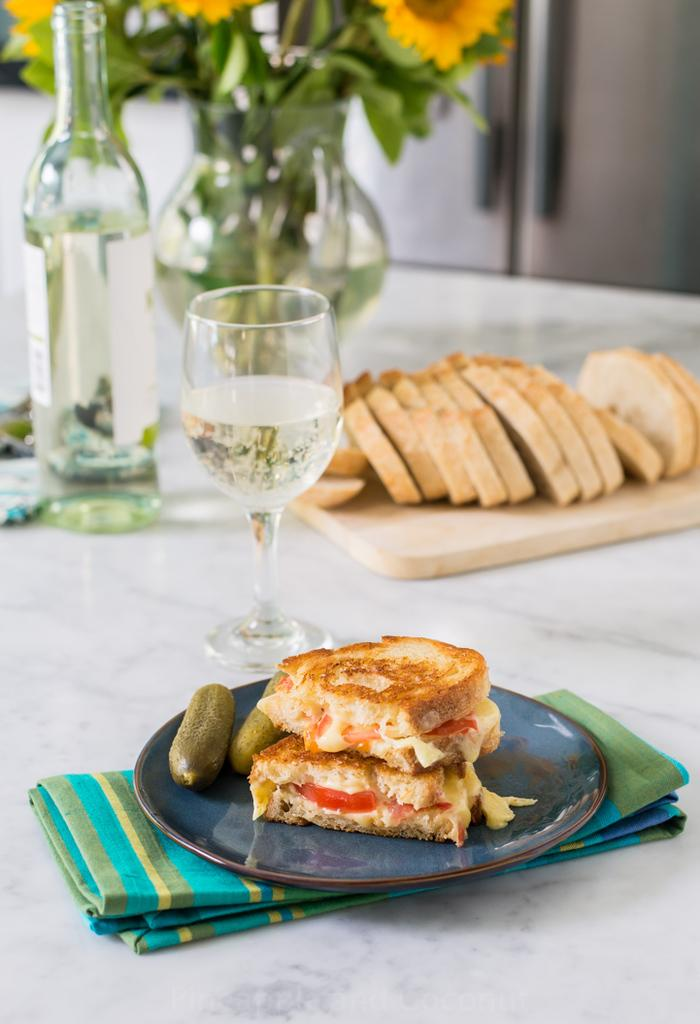What type of container is visible in the image? There is a glass and a glass bottle in the image. What else can be seen on the surface in the image? There is a plate in the image. Can you describe any other objects in the image? There are other unspecified objects in the image. How many balls are being used as a utensil in the image? There are no balls being used as a utensil in the image. What type of wrench is visible in the image? There is no wrench present in the image. 